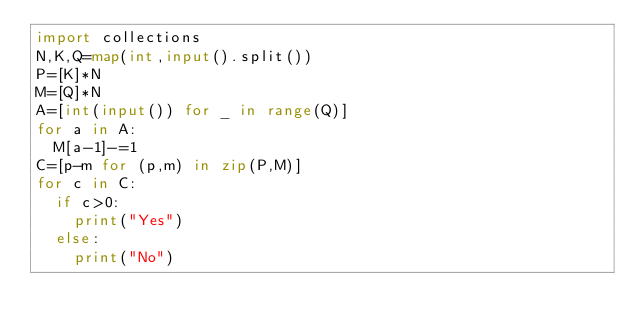<code> <loc_0><loc_0><loc_500><loc_500><_Python_>import collections
N,K,Q=map(int,input().split())
P=[K]*N
M=[Q]*N
A=[int(input()) for _ in range(Q)]
for a in A:
  M[a-1]-=1
C=[p-m for (p,m) in zip(P,M)]
for c in C:
  if c>0:
    print("Yes")
  else:
    print("No")</code> 